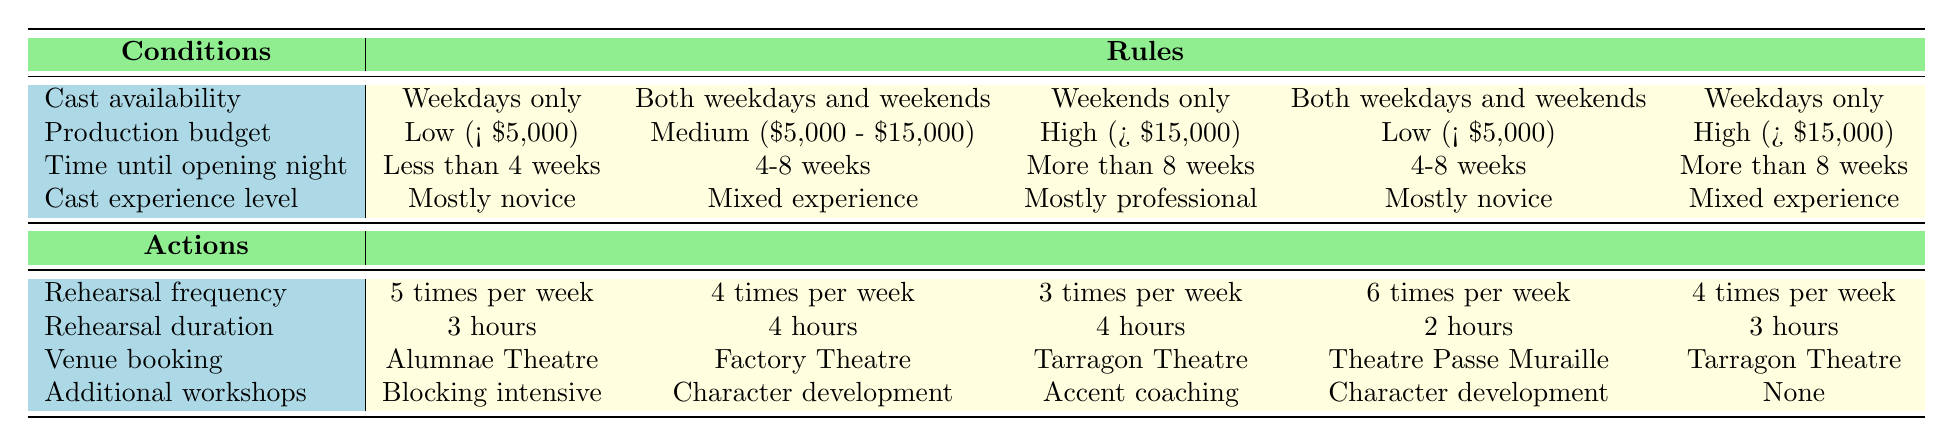What rehearsal frequency is recommended for a cast that is available only on weekends and has a high budget? According to the table, for the condition "Weekends only" and "High (> $15,000)", the recommended rehearsal frequency is "3 times per week."
Answer: 3 times per week If the production has a low budget and the cast is mostly novice, what venue should be booked? The table indicates that for the conditions "Low (< $5,000)" and "Mostly novice", the venue should be "Alumnae Theatre."
Answer: Alumnae Theatre What is the rehearsal duration when the cast has both weekdays and weekends available, a medium budget, and mixed experience? The corresponding actions for "Both weekdays and weekends", "Medium ($5,000 - $15,000)", and "Mixed experience" indicate a rehearsal duration of "4 hours."
Answer: 4 hours Are additional workshops included when the production has low budget and novice experience and the rehearsal frequency is six times per week? According to the table, for the conditions outlined, the additional workshop is "Character development." This means workshops are included, making the answer "yes."
Answer: Yes What is the average rehearsal duration across all the rules listed? The durations to consider are: 3 hours, 4 hours, 4 hours, 2 hours, and 3 hours. Adding these gives 3 + 4 + 4 + 2 + 3 = 16 hours. Dividing by the number of rules (5) gives an average of 16 / 5 = 3.2 hours.
Answer: 3.2 hours What is the action when the cast is mostly professional and the time until opening night is more than 8 weeks? The table specifies that with "Mostly professional" and "More than 8 weeks", the actions include a rehearsal frequency of "3 times per week", a rehearsal duration of "4 hours", "Tarragon Theatre" for venue, and "Accent coaching" for workshops.
Answer: 3 times per week, 4 hours, Tarragon Theatre, Accent coaching If the production time until opening night is less than 4 weeks, what would be the actions recommended? For the condition "Less than 4 weeks", the rules specify actions of "5 times per week", "3 hours", "Alumnae Theatre", and "Blocking intensive."
Answer: 5 times per week, 3 hours, Alumnae Theatre, Blocking intensive Is it true that if the rehearsal frequency is 6 times per week, then the cast must be mostly novice? Based on the table, the frequency of 6 times per week applies when the cast availability is both weekdays and weekends, budget is low, experience is mostly novice. Thus, while mostly novice is a possibility, it's not a rule that exclusively requires it. As such, the statement is false.
Answer: False 